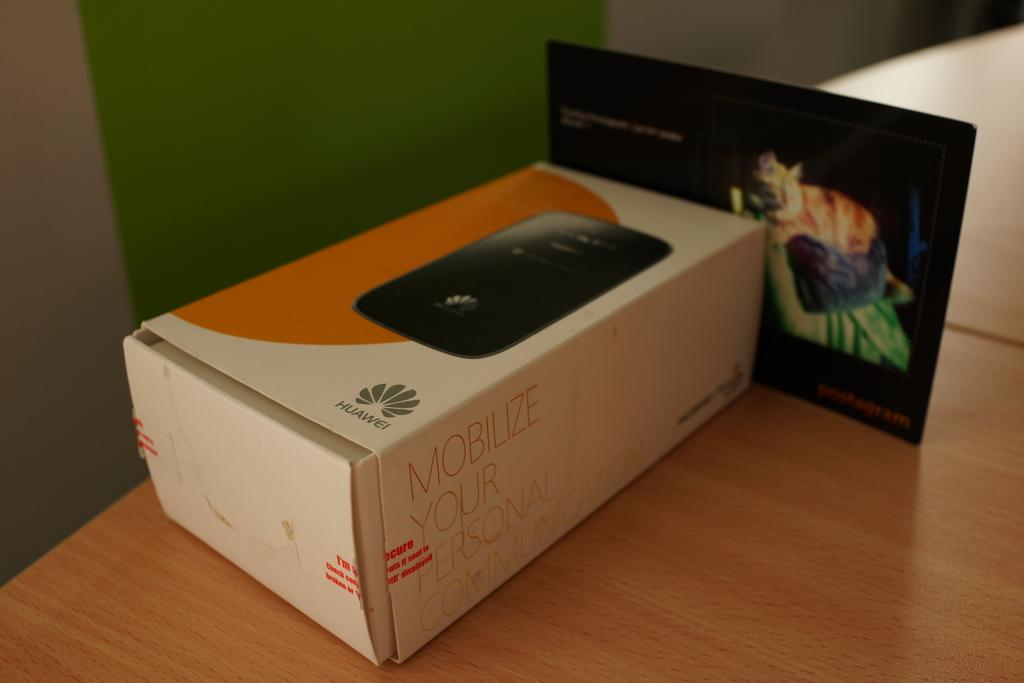<image>
Describe the image concisely. A tattered looking box holds a Huawei device for communication. 